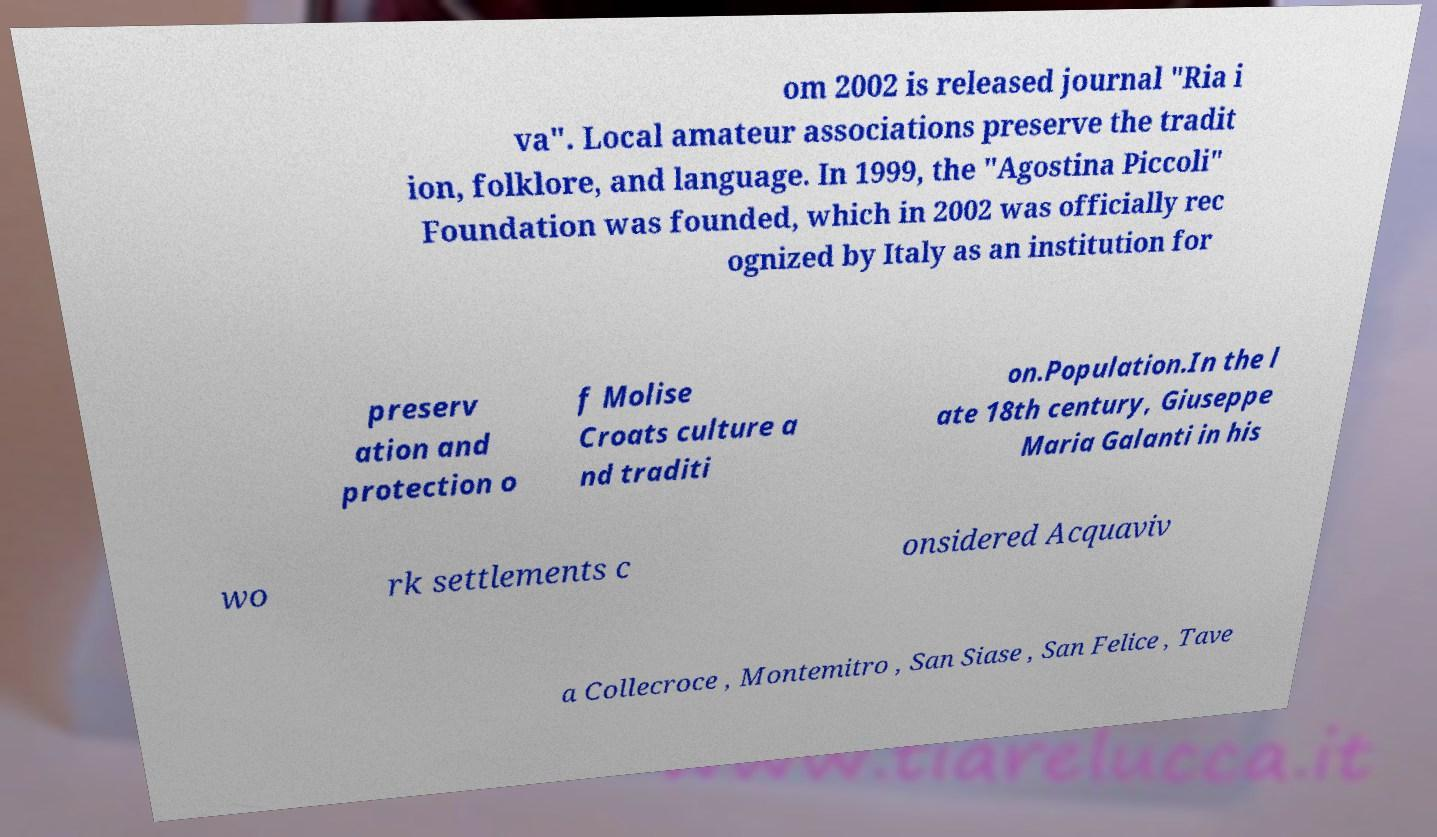Can you accurately transcribe the text from the provided image for me? om 2002 is released journal "Ria i va". Local amateur associations preserve the tradit ion, folklore, and language. In 1999, the "Agostina Piccoli" Foundation was founded, which in 2002 was officially rec ognized by Italy as an institution for preserv ation and protection o f Molise Croats culture a nd traditi on.Population.In the l ate 18th century, Giuseppe Maria Galanti in his wo rk settlements c onsidered Acquaviv a Collecroce , Montemitro , San Siase , San Felice , Tave 